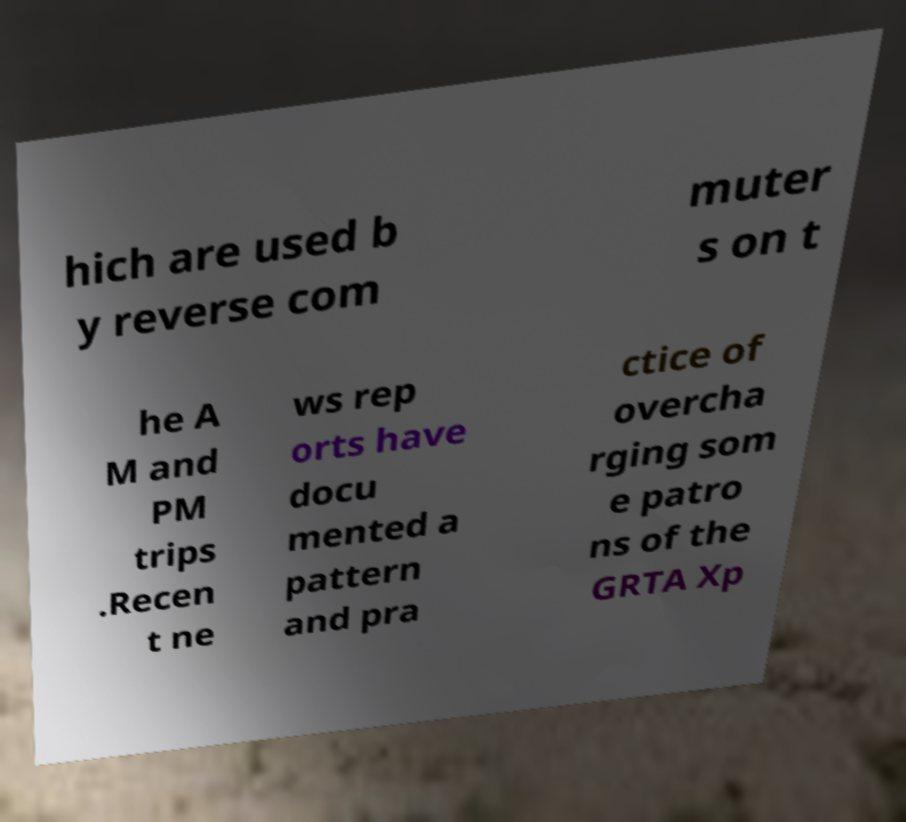Can you accurately transcribe the text from the provided image for me? hich are used b y reverse com muter s on t he A M and PM trips .Recen t ne ws rep orts have docu mented a pattern and pra ctice of overcha rging som e patro ns of the GRTA Xp 